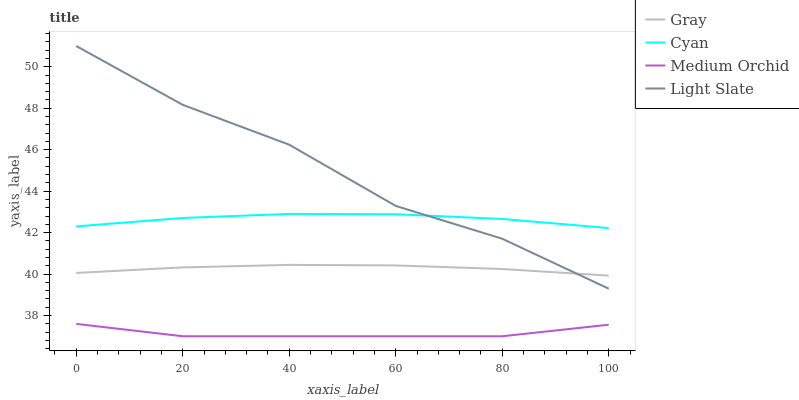Does Medium Orchid have the minimum area under the curve?
Answer yes or no. Yes. Does Light Slate have the maximum area under the curve?
Answer yes or no. Yes. Does Gray have the minimum area under the curve?
Answer yes or no. No. Does Gray have the maximum area under the curve?
Answer yes or no. No. Is Gray the smoothest?
Answer yes or no. Yes. Is Light Slate the roughest?
Answer yes or no. Yes. Is Medium Orchid the smoothest?
Answer yes or no. No. Is Medium Orchid the roughest?
Answer yes or no. No. Does Medium Orchid have the lowest value?
Answer yes or no. Yes. Does Gray have the lowest value?
Answer yes or no. No. Does Light Slate have the highest value?
Answer yes or no. Yes. Does Gray have the highest value?
Answer yes or no. No. Is Gray less than Cyan?
Answer yes or no. Yes. Is Cyan greater than Medium Orchid?
Answer yes or no. Yes. Does Gray intersect Light Slate?
Answer yes or no. Yes. Is Gray less than Light Slate?
Answer yes or no. No. Is Gray greater than Light Slate?
Answer yes or no. No. Does Gray intersect Cyan?
Answer yes or no. No. 